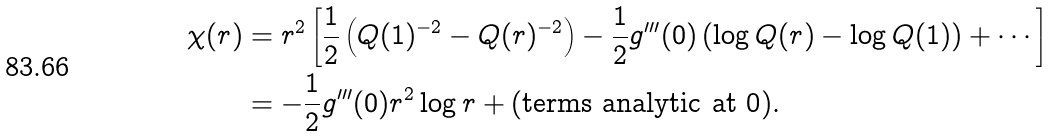Convert formula to latex. <formula><loc_0><loc_0><loc_500><loc_500>\chi ( r ) & = r ^ { 2 } \left [ \frac { 1 } { 2 } \left ( Q ( 1 ) ^ { - 2 } - Q ( r ) ^ { - 2 } \right ) - \frac { 1 } { 2 } g ^ { \prime \prime \prime } ( 0 ) \left ( \log Q ( r ) - \log Q ( 1 ) \right ) + \cdots \right ] \\ & = - \frac { 1 } { 2 } g ^ { \prime \prime \prime } ( 0 ) r ^ { 2 } \log r + ( \text {terms analytic at 0} ) .</formula> 